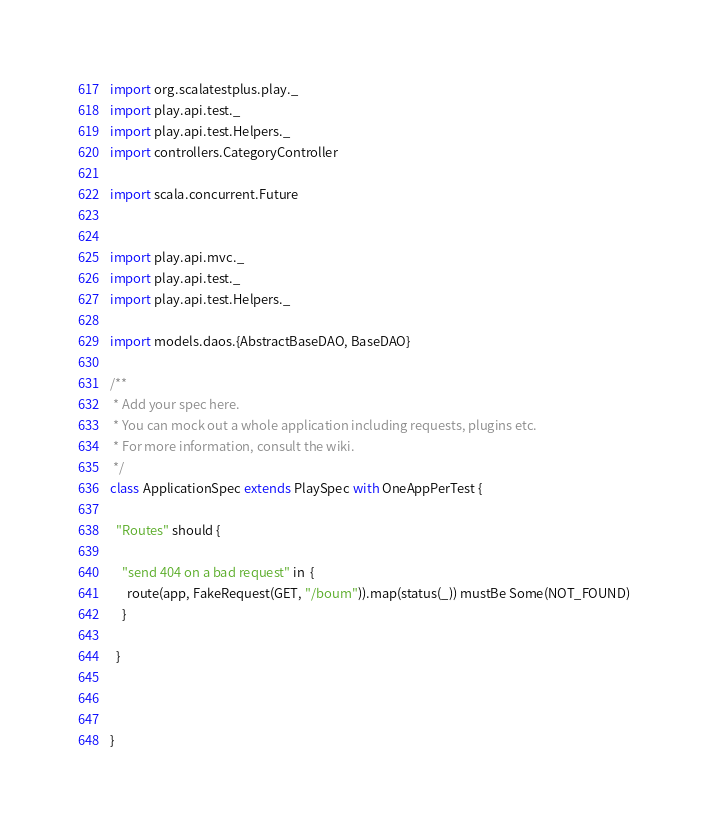Convert code to text. <code><loc_0><loc_0><loc_500><loc_500><_Scala_>import org.scalatestplus.play._
import play.api.test._
import play.api.test.Helpers._
import controllers.CategoryController

import scala.concurrent.Future


import play.api.mvc._
import play.api.test._
import play.api.test.Helpers._

import models.daos.{AbstractBaseDAO, BaseDAO}

/**
 * Add your spec here.
 * You can mock out a whole application including requests, plugins etc.
 * For more information, consult the wiki.
 */
class ApplicationSpec extends PlaySpec with OneAppPerTest {

  "Routes" should {

    "send 404 on a bad request" in  {
      route(app, FakeRequest(GET, "/boum")).map(status(_)) mustBe Some(NOT_FOUND)
    }

  }
  


}
</code> 